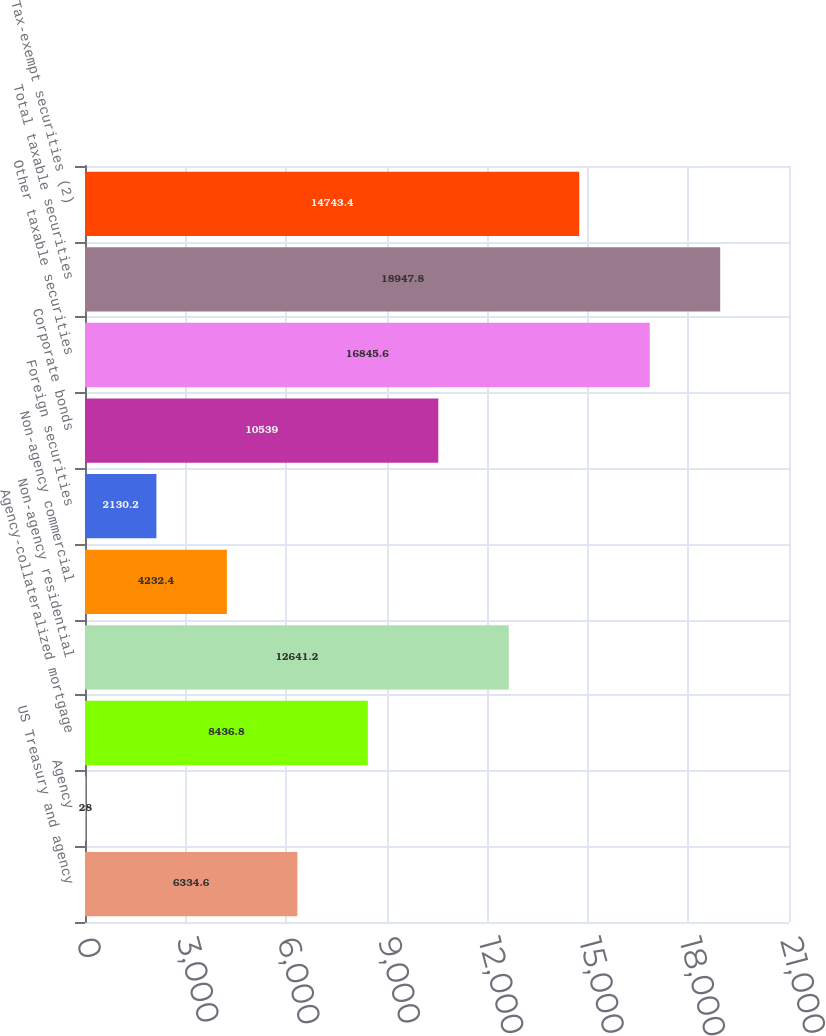Convert chart. <chart><loc_0><loc_0><loc_500><loc_500><bar_chart><fcel>US Treasury and agency<fcel>Agency<fcel>Agency-collateralized mortgage<fcel>Non-agency residential<fcel>Non-agency commercial<fcel>Foreign securities<fcel>Corporate bonds<fcel>Other taxable securities<fcel>Total taxable securities<fcel>Tax-exempt securities (2)<nl><fcel>6334.6<fcel>28<fcel>8436.8<fcel>12641.2<fcel>4232.4<fcel>2130.2<fcel>10539<fcel>16845.6<fcel>18947.8<fcel>14743.4<nl></chart> 